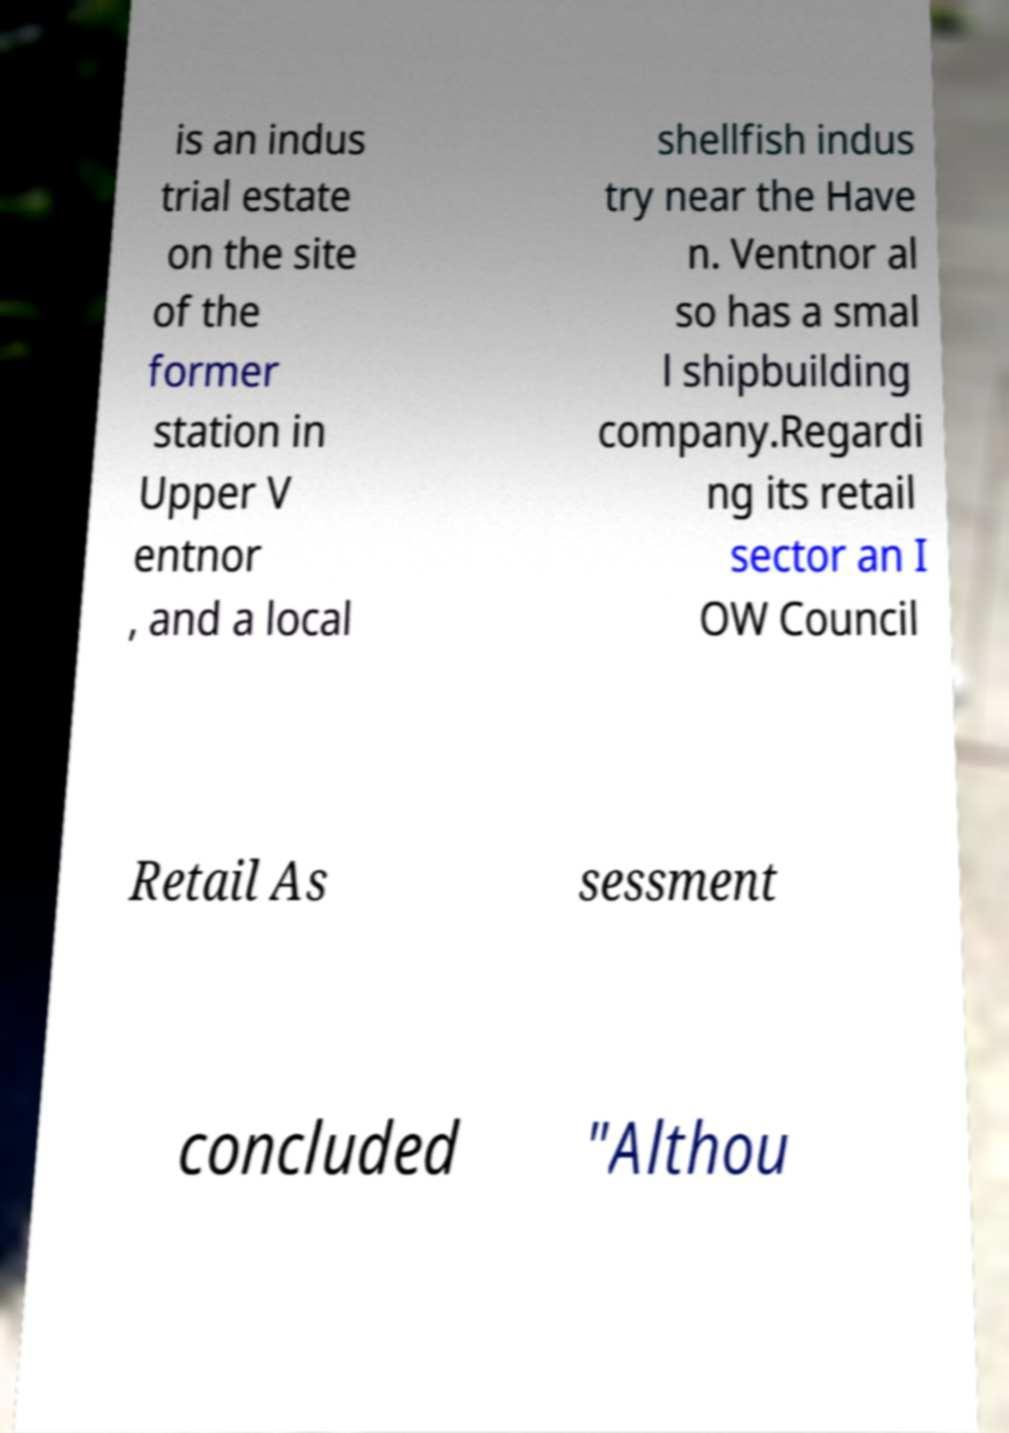Could you extract and type out the text from this image? is an indus trial estate on the site of the former station in Upper V entnor , and a local shellfish indus try near the Have n. Ventnor al so has a smal l shipbuilding company.Regardi ng its retail sector an I OW Council Retail As sessment concluded "Althou 